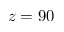Convert formula to latex. <formula><loc_0><loc_0><loc_500><loc_500>z = 9 0</formula> 